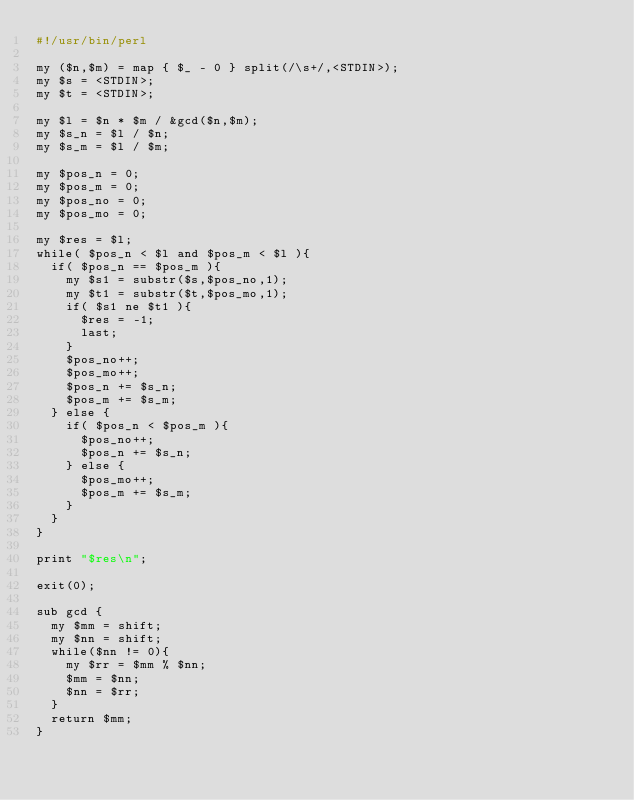Convert code to text. <code><loc_0><loc_0><loc_500><loc_500><_Perl_>#!/usr/bin/perl

my ($n,$m) = map { $_ - 0 } split(/\s+/,<STDIN>);
my $s = <STDIN>;
my $t = <STDIN>;

my $l = $n * $m / &gcd($n,$m);
my $s_n = $l / $n;
my $s_m = $l / $m;

my $pos_n = 0;
my $pos_m = 0;
my $pos_no = 0;
my $pos_mo = 0;

my $res = $l;
while( $pos_n < $l and $pos_m < $l ){
  if( $pos_n == $pos_m ){
    my $s1 = substr($s,$pos_no,1);
    my $t1 = substr($t,$pos_mo,1);
    if( $s1 ne $t1 ){
      $res = -1;
      last;
    }
    $pos_no++;
    $pos_mo++;
    $pos_n += $s_n;
    $pos_m += $s_m;
  } else {
    if( $pos_n < $pos_m ){
      $pos_no++;
      $pos_n += $s_n;
    } else {
      $pos_mo++;
      $pos_m += $s_m;
    }
  }
}

print "$res\n";

exit(0);

sub gcd {
  my $mm = shift;
  my $nn = shift;
  while($nn != 0){
    my $rr = $mm % $nn;
    $mm = $nn;
    $nn = $rr;
  }
  return $mm;
}

</code> 